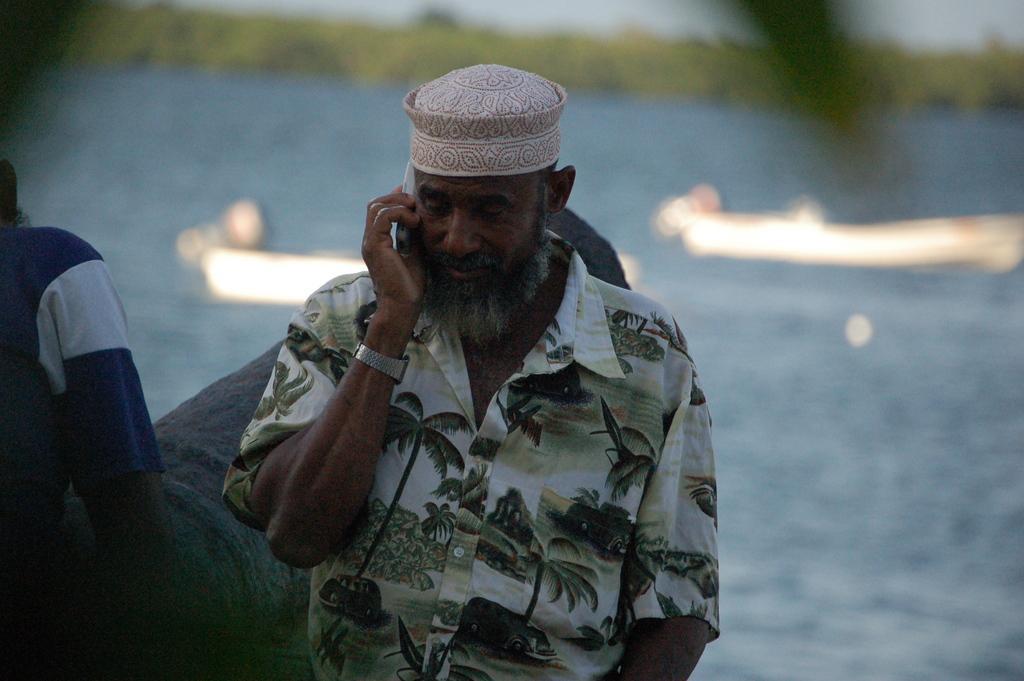Could you give a brief overview of what you see in this image? In the image we can see there are people standing and there is a man holding mobile phone in his hand. Behind there is river and there are boats docked on the water. Background of the image is little blurred. 